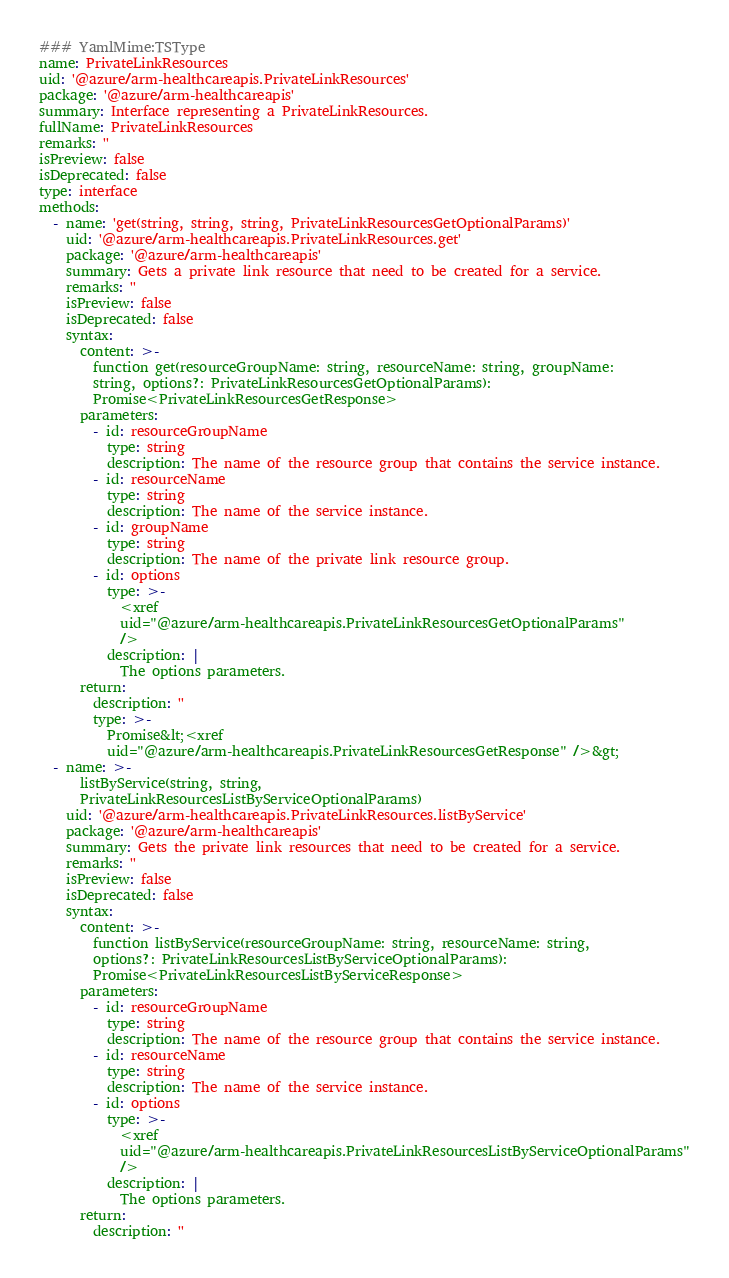Convert code to text. <code><loc_0><loc_0><loc_500><loc_500><_YAML_>### YamlMime:TSType
name: PrivateLinkResources
uid: '@azure/arm-healthcareapis.PrivateLinkResources'
package: '@azure/arm-healthcareapis'
summary: Interface representing a PrivateLinkResources.
fullName: PrivateLinkResources
remarks: ''
isPreview: false
isDeprecated: false
type: interface
methods:
  - name: 'get(string, string, string, PrivateLinkResourcesGetOptionalParams)'
    uid: '@azure/arm-healthcareapis.PrivateLinkResources.get'
    package: '@azure/arm-healthcareapis'
    summary: Gets a private link resource that need to be created for a service.
    remarks: ''
    isPreview: false
    isDeprecated: false
    syntax:
      content: >-
        function get(resourceGroupName: string, resourceName: string, groupName:
        string, options?: PrivateLinkResourcesGetOptionalParams):
        Promise<PrivateLinkResourcesGetResponse>
      parameters:
        - id: resourceGroupName
          type: string
          description: The name of the resource group that contains the service instance.
        - id: resourceName
          type: string
          description: The name of the service instance.
        - id: groupName
          type: string
          description: The name of the private link resource group.
        - id: options
          type: >-
            <xref
            uid="@azure/arm-healthcareapis.PrivateLinkResourcesGetOptionalParams"
            />
          description: |
            The options parameters.
      return:
        description: ''
        type: >-
          Promise&lt;<xref
          uid="@azure/arm-healthcareapis.PrivateLinkResourcesGetResponse" />&gt;
  - name: >-
      listByService(string, string,
      PrivateLinkResourcesListByServiceOptionalParams)
    uid: '@azure/arm-healthcareapis.PrivateLinkResources.listByService'
    package: '@azure/arm-healthcareapis'
    summary: Gets the private link resources that need to be created for a service.
    remarks: ''
    isPreview: false
    isDeprecated: false
    syntax:
      content: >-
        function listByService(resourceGroupName: string, resourceName: string,
        options?: PrivateLinkResourcesListByServiceOptionalParams):
        Promise<PrivateLinkResourcesListByServiceResponse>
      parameters:
        - id: resourceGroupName
          type: string
          description: The name of the resource group that contains the service instance.
        - id: resourceName
          type: string
          description: The name of the service instance.
        - id: options
          type: >-
            <xref
            uid="@azure/arm-healthcareapis.PrivateLinkResourcesListByServiceOptionalParams"
            />
          description: |
            The options parameters.
      return:
        description: ''</code> 